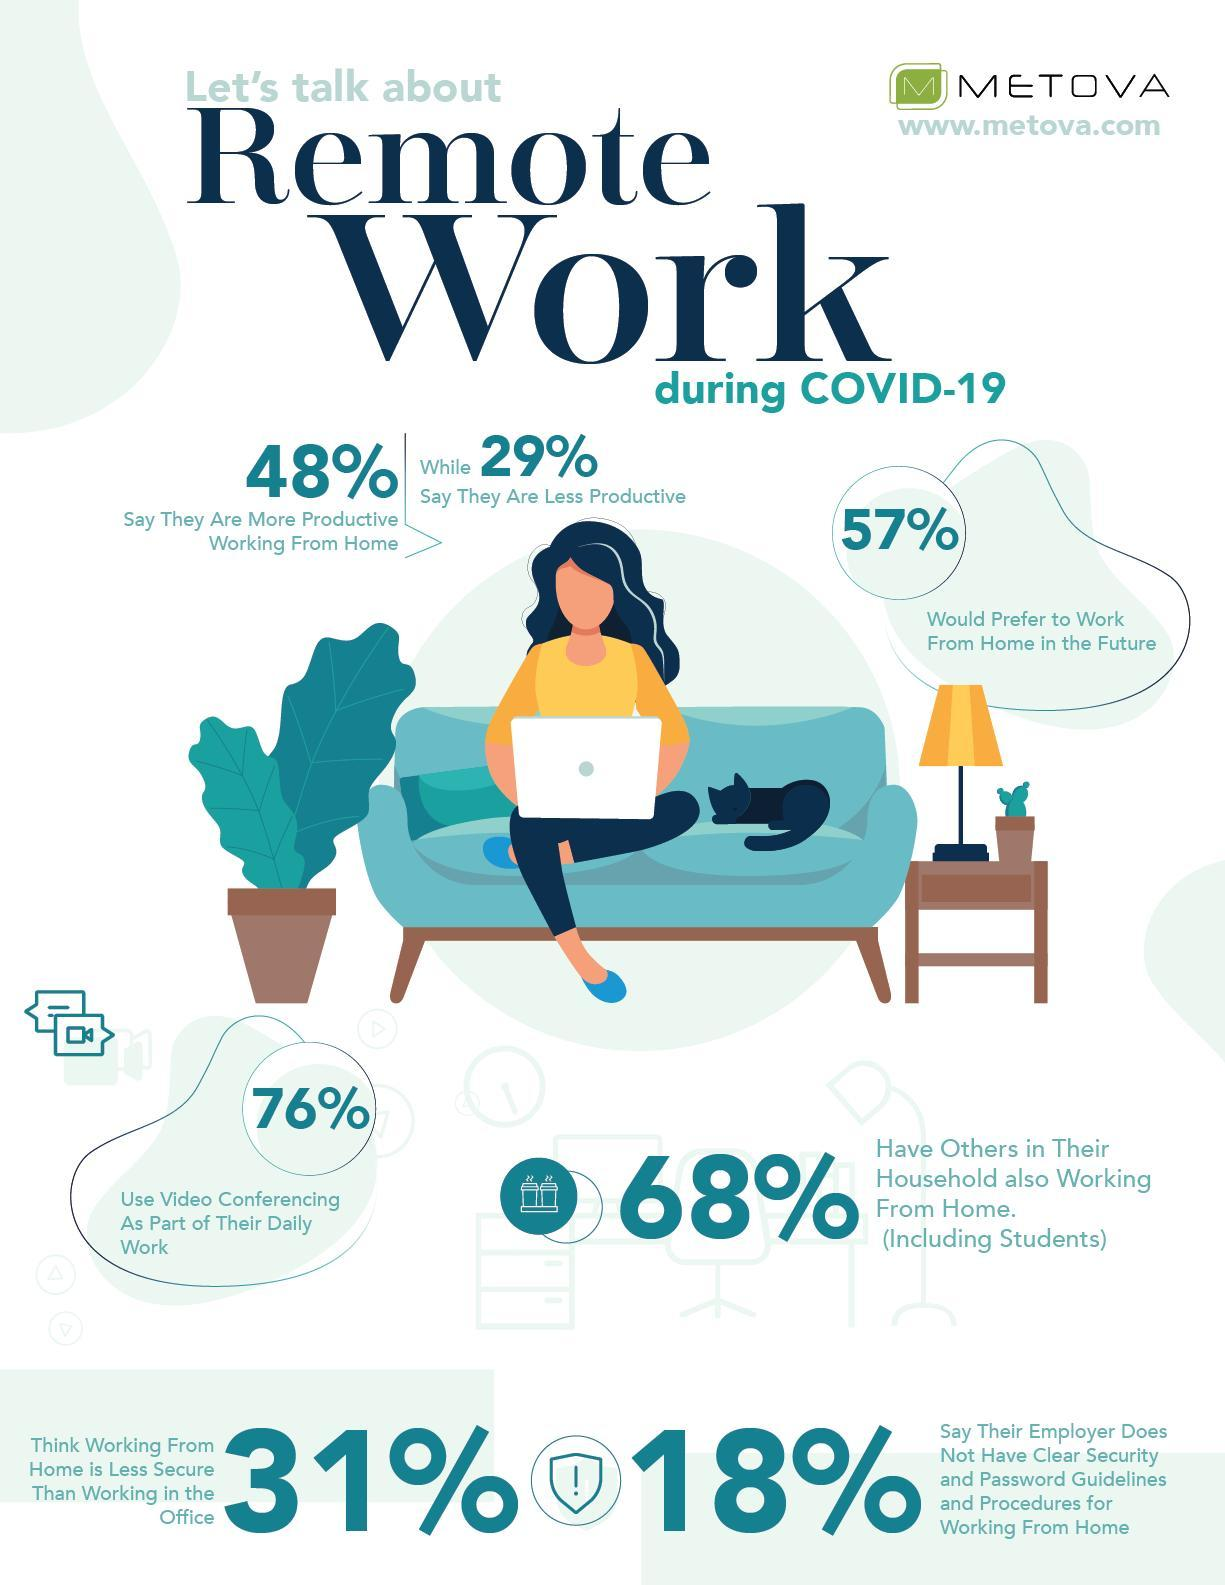What percent of people say that they are more productive while working form home during COVID-19?
Answer the question with a short phrase. 48% What percent of people do not use video conferencing as a part of their daily work? 24% What percent of people do not prefer to work from home in the future? 43% 